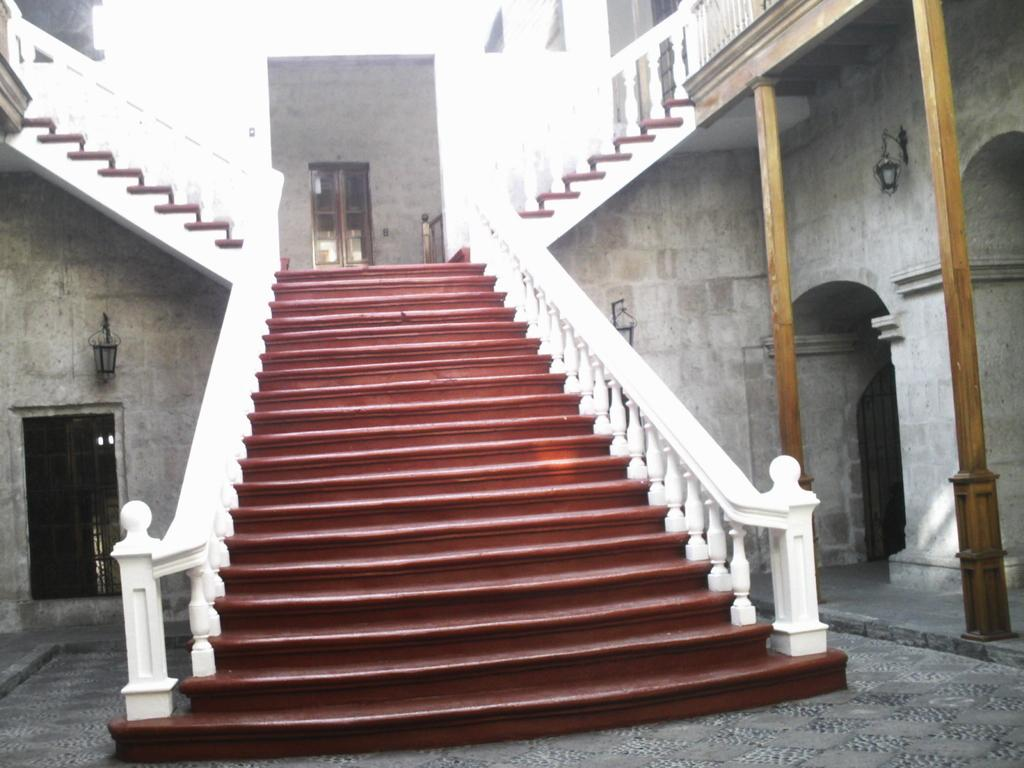What part of a building can be seen in the image? The image shows the inner part of a building. What architectural feature is present in the image? There are stairs in the image. What safety feature is included in the image? There is a railing in the image. What structural element is visible in the image? There is a wall in the image. What source of illumination is present in the image? There are lights in the image. What allows natural light to enter the building in the image? There are windows in the image. What type of knowledge is being shared in the image? There is no indication of knowledge being shared in the image; it primarily focuses on the architectural and structural elements of the building. 